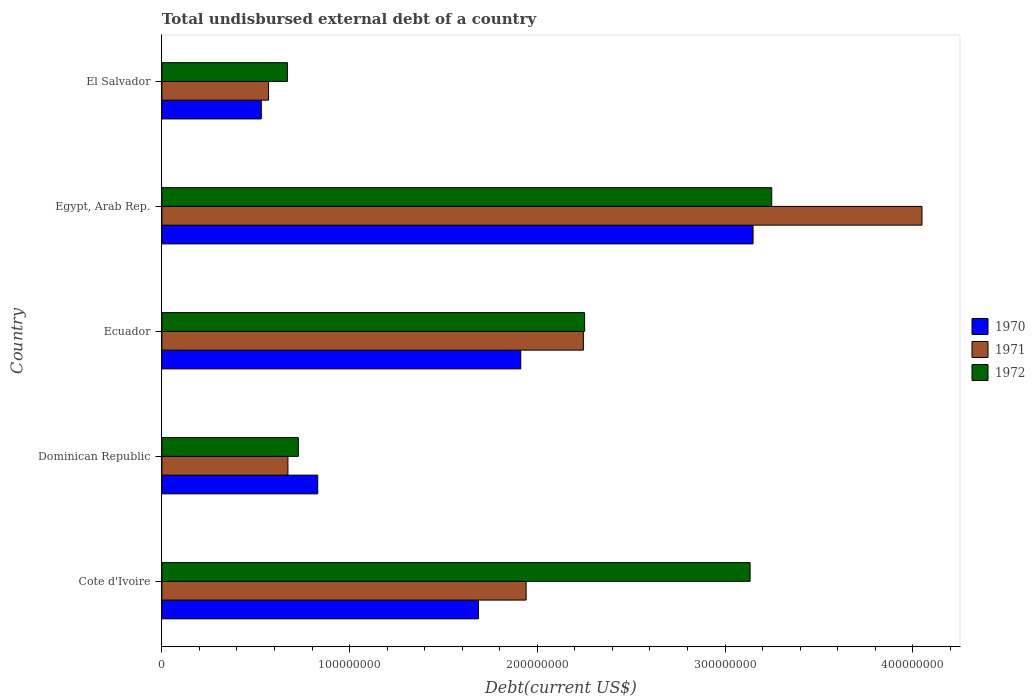How many different coloured bars are there?
Give a very brief answer. 3. Are the number of bars per tick equal to the number of legend labels?
Provide a succinct answer. Yes. Are the number of bars on each tick of the Y-axis equal?
Ensure brevity in your answer.  Yes. How many bars are there on the 2nd tick from the top?
Make the answer very short. 3. How many bars are there on the 5th tick from the bottom?
Your answer should be compact. 3. What is the label of the 5th group of bars from the top?
Give a very brief answer. Cote d'Ivoire. In how many cases, is the number of bars for a given country not equal to the number of legend labels?
Provide a succinct answer. 0. What is the total undisbursed external debt in 1972 in Egypt, Arab Rep.?
Make the answer very short. 3.25e+08. Across all countries, what is the maximum total undisbursed external debt in 1972?
Offer a very short reply. 3.25e+08. Across all countries, what is the minimum total undisbursed external debt in 1971?
Your response must be concise. 5.68e+07. In which country was the total undisbursed external debt in 1970 maximum?
Your answer should be compact. Egypt, Arab Rep. In which country was the total undisbursed external debt in 1971 minimum?
Offer a terse response. El Salvador. What is the total total undisbursed external debt in 1971 in the graph?
Give a very brief answer. 9.47e+08. What is the difference between the total undisbursed external debt in 1971 in Cote d'Ivoire and that in Egypt, Arab Rep.?
Your response must be concise. -2.11e+08. What is the difference between the total undisbursed external debt in 1972 in Cote d'Ivoire and the total undisbursed external debt in 1970 in Ecuador?
Offer a terse response. 1.22e+08. What is the average total undisbursed external debt in 1970 per country?
Keep it short and to the point. 1.62e+08. What is the difference between the total undisbursed external debt in 1970 and total undisbursed external debt in 1971 in El Salvador?
Keep it short and to the point. -3.85e+06. In how many countries, is the total undisbursed external debt in 1970 greater than 300000000 US$?
Your response must be concise. 1. What is the ratio of the total undisbursed external debt in 1971 in Ecuador to that in Egypt, Arab Rep.?
Your answer should be compact. 0.55. Is the total undisbursed external debt in 1970 in Dominican Republic less than that in Ecuador?
Provide a short and direct response. Yes. What is the difference between the highest and the second highest total undisbursed external debt in 1970?
Give a very brief answer. 1.24e+08. What is the difference between the highest and the lowest total undisbursed external debt in 1971?
Make the answer very short. 3.48e+08. What does the 3rd bar from the top in Ecuador represents?
Your answer should be compact. 1970. What does the 1st bar from the bottom in El Salvador represents?
Provide a succinct answer. 1970. How many bars are there?
Give a very brief answer. 15. Are all the bars in the graph horizontal?
Your answer should be very brief. Yes. Does the graph contain any zero values?
Give a very brief answer. No. How are the legend labels stacked?
Ensure brevity in your answer.  Vertical. What is the title of the graph?
Keep it short and to the point. Total undisbursed external debt of a country. Does "1973" appear as one of the legend labels in the graph?
Provide a short and direct response. No. What is the label or title of the X-axis?
Give a very brief answer. Debt(current US$). What is the Debt(current US$) in 1970 in Cote d'Ivoire?
Offer a very short reply. 1.69e+08. What is the Debt(current US$) in 1971 in Cote d'Ivoire?
Your answer should be very brief. 1.94e+08. What is the Debt(current US$) in 1972 in Cote d'Ivoire?
Provide a succinct answer. 3.13e+08. What is the Debt(current US$) of 1970 in Dominican Republic?
Ensure brevity in your answer.  8.30e+07. What is the Debt(current US$) of 1971 in Dominican Republic?
Keep it short and to the point. 6.71e+07. What is the Debt(current US$) in 1972 in Dominican Republic?
Give a very brief answer. 7.27e+07. What is the Debt(current US$) in 1970 in Ecuador?
Provide a short and direct response. 1.91e+08. What is the Debt(current US$) in 1971 in Ecuador?
Provide a succinct answer. 2.25e+08. What is the Debt(current US$) in 1972 in Ecuador?
Provide a succinct answer. 2.25e+08. What is the Debt(current US$) of 1970 in Egypt, Arab Rep.?
Your answer should be very brief. 3.15e+08. What is the Debt(current US$) of 1971 in Egypt, Arab Rep.?
Make the answer very short. 4.05e+08. What is the Debt(current US$) of 1972 in Egypt, Arab Rep.?
Your answer should be compact. 3.25e+08. What is the Debt(current US$) in 1970 in El Salvador?
Your answer should be compact. 5.30e+07. What is the Debt(current US$) of 1971 in El Salvador?
Provide a short and direct response. 5.68e+07. What is the Debt(current US$) in 1972 in El Salvador?
Your answer should be compact. 6.69e+07. Across all countries, what is the maximum Debt(current US$) of 1970?
Offer a very short reply. 3.15e+08. Across all countries, what is the maximum Debt(current US$) in 1971?
Give a very brief answer. 4.05e+08. Across all countries, what is the maximum Debt(current US$) in 1972?
Give a very brief answer. 3.25e+08. Across all countries, what is the minimum Debt(current US$) of 1970?
Provide a succinct answer. 5.30e+07. Across all countries, what is the minimum Debt(current US$) of 1971?
Your answer should be very brief. 5.68e+07. Across all countries, what is the minimum Debt(current US$) in 1972?
Ensure brevity in your answer.  6.69e+07. What is the total Debt(current US$) of 1970 in the graph?
Keep it short and to the point. 8.11e+08. What is the total Debt(current US$) in 1971 in the graph?
Your answer should be very brief. 9.47e+08. What is the total Debt(current US$) in 1972 in the graph?
Your answer should be very brief. 1.00e+09. What is the difference between the Debt(current US$) in 1970 in Cote d'Ivoire and that in Dominican Republic?
Provide a succinct answer. 8.56e+07. What is the difference between the Debt(current US$) of 1971 in Cote d'Ivoire and that in Dominican Republic?
Provide a succinct answer. 1.27e+08. What is the difference between the Debt(current US$) of 1972 in Cote d'Ivoire and that in Dominican Republic?
Your response must be concise. 2.41e+08. What is the difference between the Debt(current US$) in 1970 in Cote d'Ivoire and that in Ecuador?
Ensure brevity in your answer.  -2.25e+07. What is the difference between the Debt(current US$) of 1971 in Cote d'Ivoire and that in Ecuador?
Your answer should be compact. -3.05e+07. What is the difference between the Debt(current US$) in 1972 in Cote d'Ivoire and that in Ecuador?
Offer a very short reply. 8.82e+07. What is the difference between the Debt(current US$) in 1970 in Cote d'Ivoire and that in Egypt, Arab Rep.?
Give a very brief answer. -1.46e+08. What is the difference between the Debt(current US$) in 1971 in Cote d'Ivoire and that in Egypt, Arab Rep.?
Offer a very short reply. -2.11e+08. What is the difference between the Debt(current US$) in 1972 in Cote d'Ivoire and that in Egypt, Arab Rep.?
Offer a very short reply. -1.15e+07. What is the difference between the Debt(current US$) of 1970 in Cote d'Ivoire and that in El Salvador?
Provide a succinct answer. 1.16e+08. What is the difference between the Debt(current US$) of 1971 in Cote d'Ivoire and that in El Salvador?
Ensure brevity in your answer.  1.37e+08. What is the difference between the Debt(current US$) of 1972 in Cote d'Ivoire and that in El Salvador?
Give a very brief answer. 2.46e+08. What is the difference between the Debt(current US$) of 1970 in Dominican Republic and that in Ecuador?
Provide a succinct answer. -1.08e+08. What is the difference between the Debt(current US$) of 1971 in Dominican Republic and that in Ecuador?
Make the answer very short. -1.57e+08. What is the difference between the Debt(current US$) of 1972 in Dominican Republic and that in Ecuador?
Your response must be concise. -1.53e+08. What is the difference between the Debt(current US$) in 1970 in Dominican Republic and that in Egypt, Arab Rep.?
Your answer should be compact. -2.32e+08. What is the difference between the Debt(current US$) of 1971 in Dominican Republic and that in Egypt, Arab Rep.?
Ensure brevity in your answer.  -3.38e+08. What is the difference between the Debt(current US$) of 1972 in Dominican Republic and that in Egypt, Arab Rep.?
Make the answer very short. -2.52e+08. What is the difference between the Debt(current US$) in 1970 in Dominican Republic and that in El Salvador?
Provide a short and direct response. 3.01e+07. What is the difference between the Debt(current US$) of 1971 in Dominican Republic and that in El Salvador?
Offer a terse response. 1.03e+07. What is the difference between the Debt(current US$) of 1972 in Dominican Republic and that in El Salvador?
Ensure brevity in your answer.  5.80e+06. What is the difference between the Debt(current US$) in 1970 in Ecuador and that in Egypt, Arab Rep.?
Provide a succinct answer. -1.24e+08. What is the difference between the Debt(current US$) in 1971 in Ecuador and that in Egypt, Arab Rep.?
Offer a very short reply. -1.80e+08. What is the difference between the Debt(current US$) of 1972 in Ecuador and that in Egypt, Arab Rep.?
Provide a succinct answer. -9.97e+07. What is the difference between the Debt(current US$) of 1970 in Ecuador and that in El Salvador?
Offer a very short reply. 1.38e+08. What is the difference between the Debt(current US$) of 1971 in Ecuador and that in El Salvador?
Offer a very short reply. 1.68e+08. What is the difference between the Debt(current US$) in 1972 in Ecuador and that in El Salvador?
Your response must be concise. 1.58e+08. What is the difference between the Debt(current US$) of 1970 in Egypt, Arab Rep. and that in El Salvador?
Your answer should be compact. 2.62e+08. What is the difference between the Debt(current US$) of 1971 in Egypt, Arab Rep. and that in El Salvador?
Provide a short and direct response. 3.48e+08. What is the difference between the Debt(current US$) of 1972 in Egypt, Arab Rep. and that in El Salvador?
Make the answer very short. 2.58e+08. What is the difference between the Debt(current US$) of 1970 in Cote d'Ivoire and the Debt(current US$) of 1971 in Dominican Republic?
Offer a very short reply. 1.02e+08. What is the difference between the Debt(current US$) of 1970 in Cote d'Ivoire and the Debt(current US$) of 1972 in Dominican Republic?
Give a very brief answer. 9.60e+07. What is the difference between the Debt(current US$) in 1971 in Cote d'Ivoire and the Debt(current US$) in 1972 in Dominican Republic?
Give a very brief answer. 1.21e+08. What is the difference between the Debt(current US$) in 1970 in Cote d'Ivoire and the Debt(current US$) in 1971 in Ecuador?
Provide a short and direct response. -5.59e+07. What is the difference between the Debt(current US$) in 1970 in Cote d'Ivoire and the Debt(current US$) in 1972 in Ecuador?
Make the answer very short. -5.66e+07. What is the difference between the Debt(current US$) in 1971 in Cote d'Ivoire and the Debt(current US$) in 1972 in Ecuador?
Give a very brief answer. -3.12e+07. What is the difference between the Debt(current US$) in 1970 in Cote d'Ivoire and the Debt(current US$) in 1971 in Egypt, Arab Rep.?
Make the answer very short. -2.36e+08. What is the difference between the Debt(current US$) in 1970 in Cote d'Ivoire and the Debt(current US$) in 1972 in Egypt, Arab Rep.?
Your answer should be very brief. -1.56e+08. What is the difference between the Debt(current US$) in 1971 in Cote d'Ivoire and the Debt(current US$) in 1972 in Egypt, Arab Rep.?
Make the answer very short. -1.31e+08. What is the difference between the Debt(current US$) of 1970 in Cote d'Ivoire and the Debt(current US$) of 1971 in El Salvador?
Ensure brevity in your answer.  1.12e+08. What is the difference between the Debt(current US$) in 1970 in Cote d'Ivoire and the Debt(current US$) in 1972 in El Salvador?
Make the answer very short. 1.02e+08. What is the difference between the Debt(current US$) of 1971 in Cote d'Ivoire and the Debt(current US$) of 1972 in El Salvador?
Your response must be concise. 1.27e+08. What is the difference between the Debt(current US$) in 1970 in Dominican Republic and the Debt(current US$) in 1971 in Ecuador?
Your answer should be compact. -1.42e+08. What is the difference between the Debt(current US$) in 1970 in Dominican Republic and the Debt(current US$) in 1972 in Ecuador?
Your response must be concise. -1.42e+08. What is the difference between the Debt(current US$) of 1971 in Dominican Republic and the Debt(current US$) of 1972 in Ecuador?
Make the answer very short. -1.58e+08. What is the difference between the Debt(current US$) in 1970 in Dominican Republic and the Debt(current US$) in 1971 in Egypt, Arab Rep.?
Give a very brief answer. -3.22e+08. What is the difference between the Debt(current US$) in 1970 in Dominican Republic and the Debt(current US$) in 1972 in Egypt, Arab Rep.?
Ensure brevity in your answer.  -2.42e+08. What is the difference between the Debt(current US$) of 1971 in Dominican Republic and the Debt(current US$) of 1972 in Egypt, Arab Rep.?
Provide a succinct answer. -2.58e+08. What is the difference between the Debt(current US$) of 1970 in Dominican Republic and the Debt(current US$) of 1971 in El Salvador?
Provide a short and direct response. 2.62e+07. What is the difference between the Debt(current US$) in 1970 in Dominican Republic and the Debt(current US$) in 1972 in El Salvador?
Your answer should be very brief. 1.61e+07. What is the difference between the Debt(current US$) of 1971 in Dominican Republic and the Debt(current US$) of 1972 in El Salvador?
Make the answer very short. 2.60e+05. What is the difference between the Debt(current US$) in 1970 in Ecuador and the Debt(current US$) in 1971 in Egypt, Arab Rep.?
Provide a succinct answer. -2.14e+08. What is the difference between the Debt(current US$) in 1970 in Ecuador and the Debt(current US$) in 1972 in Egypt, Arab Rep.?
Your answer should be compact. -1.34e+08. What is the difference between the Debt(current US$) of 1971 in Ecuador and the Debt(current US$) of 1972 in Egypt, Arab Rep.?
Make the answer very short. -1.00e+08. What is the difference between the Debt(current US$) in 1970 in Ecuador and the Debt(current US$) in 1971 in El Salvador?
Your answer should be compact. 1.34e+08. What is the difference between the Debt(current US$) in 1970 in Ecuador and the Debt(current US$) in 1972 in El Salvador?
Provide a short and direct response. 1.24e+08. What is the difference between the Debt(current US$) of 1971 in Ecuador and the Debt(current US$) of 1972 in El Salvador?
Provide a short and direct response. 1.58e+08. What is the difference between the Debt(current US$) of 1970 in Egypt, Arab Rep. and the Debt(current US$) of 1971 in El Salvador?
Make the answer very short. 2.58e+08. What is the difference between the Debt(current US$) in 1970 in Egypt, Arab Rep. and the Debt(current US$) in 1972 in El Salvador?
Provide a succinct answer. 2.48e+08. What is the difference between the Debt(current US$) of 1971 in Egypt, Arab Rep. and the Debt(current US$) of 1972 in El Salvador?
Give a very brief answer. 3.38e+08. What is the average Debt(current US$) of 1970 per country?
Offer a very short reply. 1.62e+08. What is the average Debt(current US$) of 1971 per country?
Provide a succinct answer. 1.89e+08. What is the average Debt(current US$) in 1972 per country?
Provide a short and direct response. 2.01e+08. What is the difference between the Debt(current US$) in 1970 and Debt(current US$) in 1971 in Cote d'Ivoire?
Keep it short and to the point. -2.54e+07. What is the difference between the Debt(current US$) in 1970 and Debt(current US$) in 1972 in Cote d'Ivoire?
Provide a succinct answer. -1.45e+08. What is the difference between the Debt(current US$) of 1971 and Debt(current US$) of 1972 in Cote d'Ivoire?
Provide a succinct answer. -1.19e+08. What is the difference between the Debt(current US$) in 1970 and Debt(current US$) in 1971 in Dominican Republic?
Ensure brevity in your answer.  1.59e+07. What is the difference between the Debt(current US$) in 1970 and Debt(current US$) in 1972 in Dominican Republic?
Offer a terse response. 1.04e+07. What is the difference between the Debt(current US$) of 1971 and Debt(current US$) of 1972 in Dominican Republic?
Offer a terse response. -5.54e+06. What is the difference between the Debt(current US$) in 1970 and Debt(current US$) in 1971 in Ecuador?
Offer a very short reply. -3.34e+07. What is the difference between the Debt(current US$) of 1970 and Debt(current US$) of 1972 in Ecuador?
Give a very brief answer. -3.40e+07. What is the difference between the Debt(current US$) in 1971 and Debt(current US$) in 1972 in Ecuador?
Give a very brief answer. -6.61e+05. What is the difference between the Debt(current US$) of 1970 and Debt(current US$) of 1971 in Egypt, Arab Rep.?
Ensure brevity in your answer.  -9.00e+07. What is the difference between the Debt(current US$) of 1970 and Debt(current US$) of 1972 in Egypt, Arab Rep.?
Your answer should be very brief. -9.93e+06. What is the difference between the Debt(current US$) in 1971 and Debt(current US$) in 1972 in Egypt, Arab Rep.?
Make the answer very short. 8.01e+07. What is the difference between the Debt(current US$) in 1970 and Debt(current US$) in 1971 in El Salvador?
Your answer should be compact. -3.85e+06. What is the difference between the Debt(current US$) of 1970 and Debt(current US$) of 1972 in El Salvador?
Give a very brief answer. -1.39e+07. What is the difference between the Debt(current US$) of 1971 and Debt(current US$) of 1972 in El Salvador?
Keep it short and to the point. -1.01e+07. What is the ratio of the Debt(current US$) of 1970 in Cote d'Ivoire to that in Dominican Republic?
Offer a terse response. 2.03. What is the ratio of the Debt(current US$) in 1971 in Cote d'Ivoire to that in Dominican Republic?
Your answer should be compact. 2.89. What is the ratio of the Debt(current US$) in 1972 in Cote d'Ivoire to that in Dominican Republic?
Your answer should be very brief. 4.31. What is the ratio of the Debt(current US$) of 1970 in Cote d'Ivoire to that in Ecuador?
Make the answer very short. 0.88. What is the ratio of the Debt(current US$) in 1971 in Cote d'Ivoire to that in Ecuador?
Keep it short and to the point. 0.86. What is the ratio of the Debt(current US$) in 1972 in Cote d'Ivoire to that in Ecuador?
Your answer should be compact. 1.39. What is the ratio of the Debt(current US$) in 1970 in Cote d'Ivoire to that in Egypt, Arab Rep.?
Give a very brief answer. 0.54. What is the ratio of the Debt(current US$) in 1971 in Cote d'Ivoire to that in Egypt, Arab Rep.?
Ensure brevity in your answer.  0.48. What is the ratio of the Debt(current US$) of 1972 in Cote d'Ivoire to that in Egypt, Arab Rep.?
Your answer should be compact. 0.96. What is the ratio of the Debt(current US$) of 1970 in Cote d'Ivoire to that in El Salvador?
Ensure brevity in your answer.  3.18. What is the ratio of the Debt(current US$) of 1971 in Cote d'Ivoire to that in El Salvador?
Offer a very short reply. 3.42. What is the ratio of the Debt(current US$) in 1972 in Cote d'Ivoire to that in El Salvador?
Keep it short and to the point. 4.69. What is the ratio of the Debt(current US$) of 1970 in Dominican Republic to that in Ecuador?
Your response must be concise. 0.43. What is the ratio of the Debt(current US$) of 1971 in Dominican Republic to that in Ecuador?
Your answer should be very brief. 0.3. What is the ratio of the Debt(current US$) in 1972 in Dominican Republic to that in Ecuador?
Provide a short and direct response. 0.32. What is the ratio of the Debt(current US$) of 1970 in Dominican Republic to that in Egypt, Arab Rep.?
Give a very brief answer. 0.26. What is the ratio of the Debt(current US$) of 1971 in Dominican Republic to that in Egypt, Arab Rep.?
Keep it short and to the point. 0.17. What is the ratio of the Debt(current US$) in 1972 in Dominican Republic to that in Egypt, Arab Rep.?
Your answer should be very brief. 0.22. What is the ratio of the Debt(current US$) of 1970 in Dominican Republic to that in El Salvador?
Make the answer very short. 1.57. What is the ratio of the Debt(current US$) of 1971 in Dominican Republic to that in El Salvador?
Offer a terse response. 1.18. What is the ratio of the Debt(current US$) in 1972 in Dominican Republic to that in El Salvador?
Your answer should be compact. 1.09. What is the ratio of the Debt(current US$) in 1970 in Ecuador to that in Egypt, Arab Rep.?
Provide a succinct answer. 0.61. What is the ratio of the Debt(current US$) of 1971 in Ecuador to that in Egypt, Arab Rep.?
Provide a short and direct response. 0.55. What is the ratio of the Debt(current US$) in 1972 in Ecuador to that in Egypt, Arab Rep.?
Offer a very short reply. 0.69. What is the ratio of the Debt(current US$) in 1970 in Ecuador to that in El Salvador?
Your answer should be compact. 3.61. What is the ratio of the Debt(current US$) in 1971 in Ecuador to that in El Salvador?
Your answer should be compact. 3.95. What is the ratio of the Debt(current US$) in 1972 in Ecuador to that in El Salvador?
Offer a very short reply. 3.37. What is the ratio of the Debt(current US$) of 1970 in Egypt, Arab Rep. to that in El Salvador?
Your answer should be compact. 5.95. What is the ratio of the Debt(current US$) in 1971 in Egypt, Arab Rep. to that in El Salvador?
Provide a succinct answer. 7.13. What is the ratio of the Debt(current US$) in 1972 in Egypt, Arab Rep. to that in El Salvador?
Provide a short and direct response. 4.86. What is the difference between the highest and the second highest Debt(current US$) of 1970?
Keep it short and to the point. 1.24e+08. What is the difference between the highest and the second highest Debt(current US$) of 1971?
Your answer should be very brief. 1.80e+08. What is the difference between the highest and the second highest Debt(current US$) of 1972?
Your answer should be compact. 1.15e+07. What is the difference between the highest and the lowest Debt(current US$) in 1970?
Make the answer very short. 2.62e+08. What is the difference between the highest and the lowest Debt(current US$) of 1971?
Provide a succinct answer. 3.48e+08. What is the difference between the highest and the lowest Debt(current US$) of 1972?
Keep it short and to the point. 2.58e+08. 